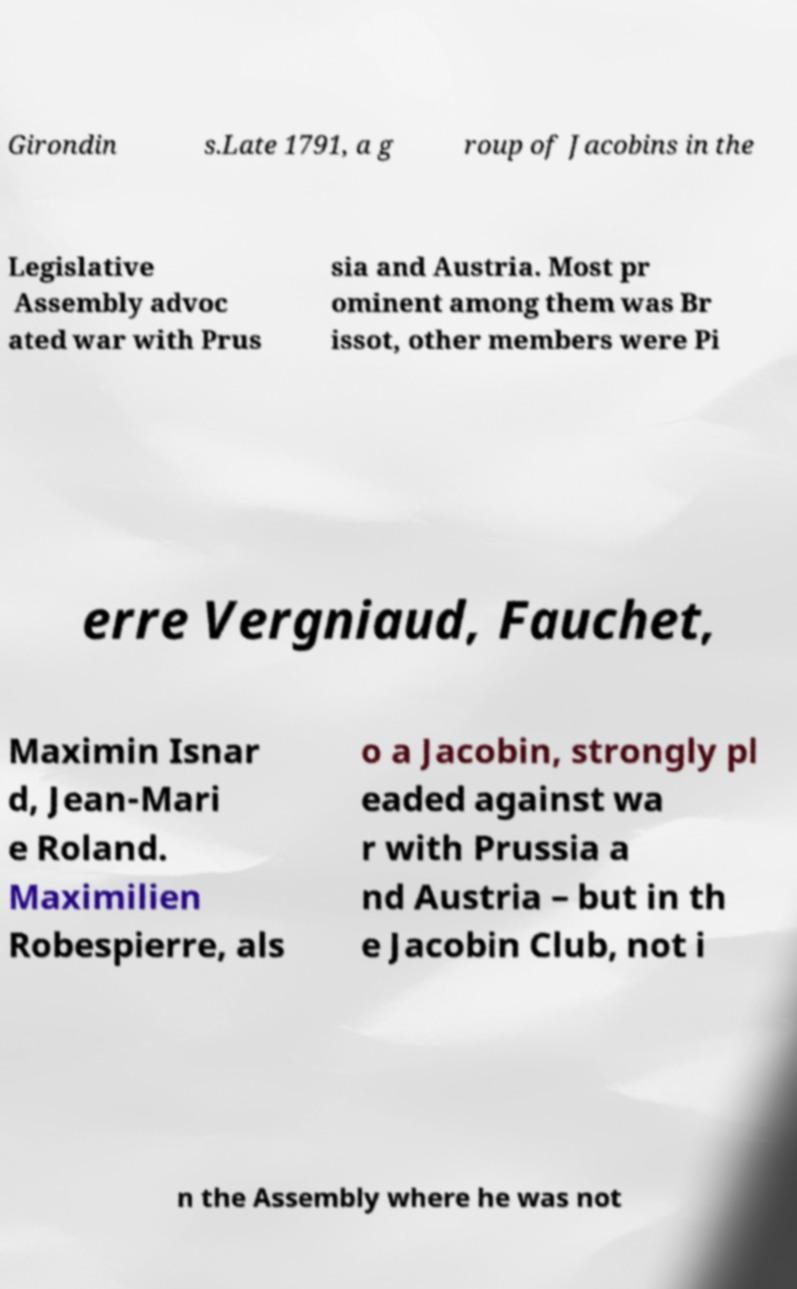I need the written content from this picture converted into text. Can you do that? Girondin s.Late 1791, a g roup of Jacobins in the Legislative Assembly advoc ated war with Prus sia and Austria. Most pr ominent among them was Br issot, other members were Pi erre Vergniaud, Fauchet, Maximin Isnar d, Jean-Mari e Roland. Maximilien Robespierre, als o a Jacobin, strongly pl eaded against wa r with Prussia a nd Austria – but in th e Jacobin Club, not i n the Assembly where he was not 